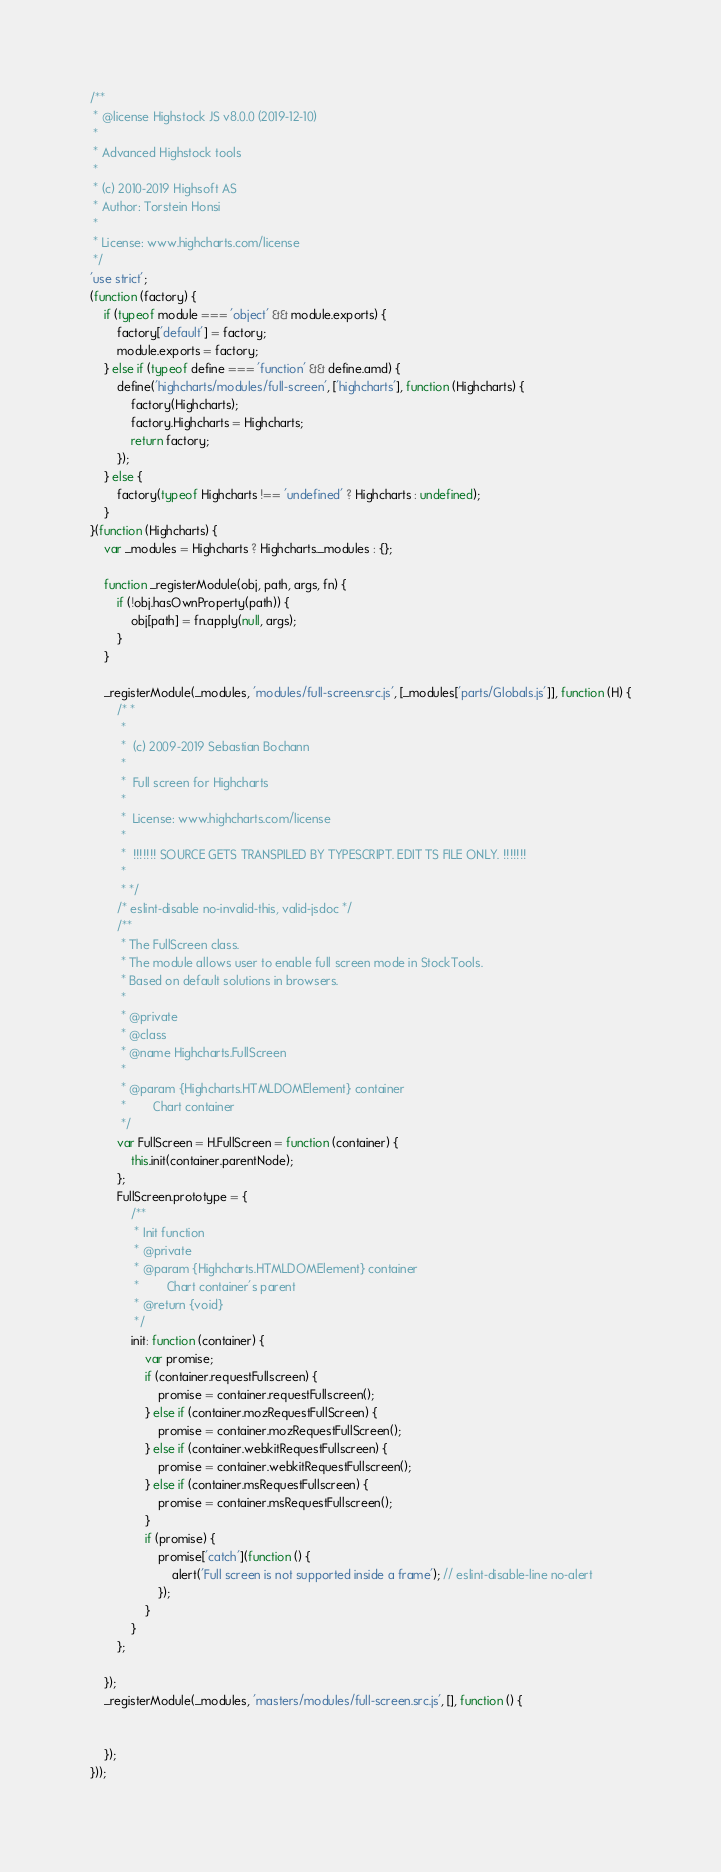<code> <loc_0><loc_0><loc_500><loc_500><_JavaScript_>/**
 * @license Highstock JS v8.0.0 (2019-12-10)
 *
 * Advanced Highstock tools
 *
 * (c) 2010-2019 Highsoft AS
 * Author: Torstein Honsi
 *
 * License: www.highcharts.com/license
 */
'use strict';
(function (factory) {
    if (typeof module === 'object' && module.exports) {
        factory['default'] = factory;
        module.exports = factory;
    } else if (typeof define === 'function' && define.amd) {
        define('highcharts/modules/full-screen', ['highcharts'], function (Highcharts) {
            factory(Highcharts);
            factory.Highcharts = Highcharts;
            return factory;
        });
    } else {
        factory(typeof Highcharts !== 'undefined' ? Highcharts : undefined);
    }
}(function (Highcharts) {
    var _modules = Highcharts ? Highcharts._modules : {};

    function _registerModule(obj, path, args, fn) {
        if (!obj.hasOwnProperty(path)) {
            obj[path] = fn.apply(null, args);
        }
    }

    _registerModule(_modules, 'modules/full-screen.src.js', [_modules['parts/Globals.js']], function (H) {
        /* *
         *
         *  (c) 2009-2019 Sebastian Bochann
         *
         *  Full screen for Highcharts
         *
         *  License: www.highcharts.com/license
         *
         *  !!!!!!! SOURCE GETS TRANSPILED BY TYPESCRIPT. EDIT TS FILE ONLY. !!!!!!!
         *
         * */
        /* eslint-disable no-invalid-this, valid-jsdoc */
        /**
         * The FullScreen class.
         * The module allows user to enable full screen mode in StockTools.
         * Based on default solutions in browsers.
         *
         * @private
         * @class
         * @name Highcharts.FullScreen
         *
         * @param {Highcharts.HTMLDOMElement} container
         *        Chart container
         */
        var FullScreen = H.FullScreen = function (container) {
            this.init(container.parentNode);
        };
        FullScreen.prototype = {
            /**
             * Init function
             * @private
             * @param {Highcharts.HTMLDOMElement} container
             *        Chart container's parent
             * @return {void}
             */
            init: function (container) {
                var promise;
                if (container.requestFullscreen) {
                    promise = container.requestFullscreen();
                } else if (container.mozRequestFullScreen) {
                    promise = container.mozRequestFullScreen();
                } else if (container.webkitRequestFullscreen) {
                    promise = container.webkitRequestFullscreen();
                } else if (container.msRequestFullscreen) {
                    promise = container.msRequestFullscreen();
                }
                if (promise) {
                    promise['catch'](function () {
                        alert('Full screen is not supported inside a frame'); // eslint-disable-line no-alert
                    });
                }
            }
        };

    });
    _registerModule(_modules, 'masters/modules/full-screen.src.js', [], function () {


    });
}));
</code> 